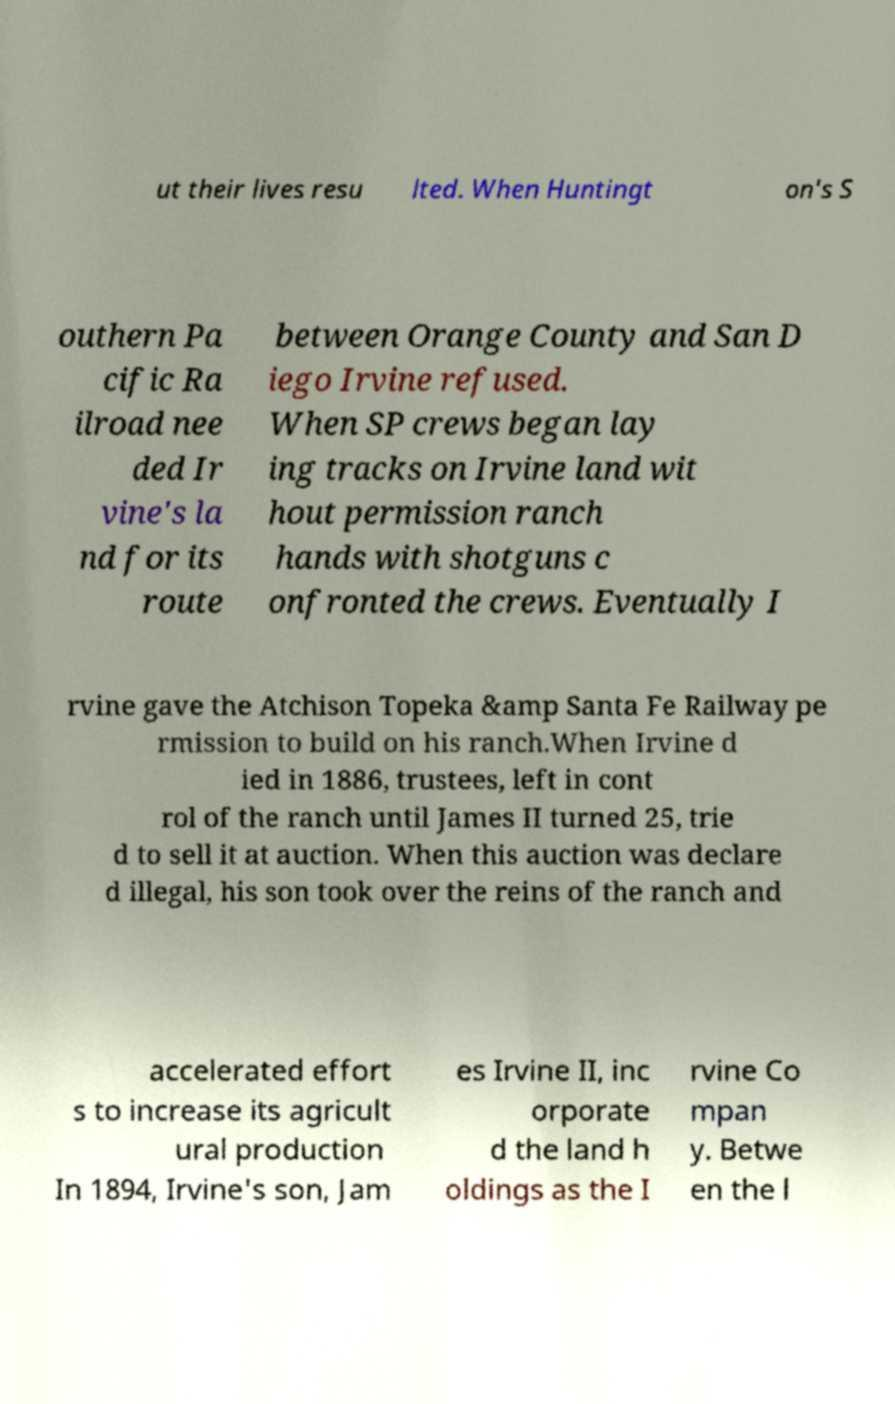Could you extract and type out the text from this image? ut their lives resu lted. When Huntingt on's S outhern Pa cific Ra ilroad nee ded Ir vine's la nd for its route between Orange County and San D iego Irvine refused. When SP crews began lay ing tracks on Irvine land wit hout permission ranch hands with shotguns c onfronted the crews. Eventually I rvine gave the Atchison Topeka &amp Santa Fe Railway pe rmission to build on his ranch.When Irvine d ied in 1886, trustees, left in cont rol of the ranch until James II turned 25, trie d to sell it at auction. When this auction was declare d illegal, his son took over the reins of the ranch and accelerated effort s to increase its agricult ural production In 1894, Irvine's son, Jam es Irvine II, inc orporate d the land h oldings as the I rvine Co mpan y. Betwe en the l 